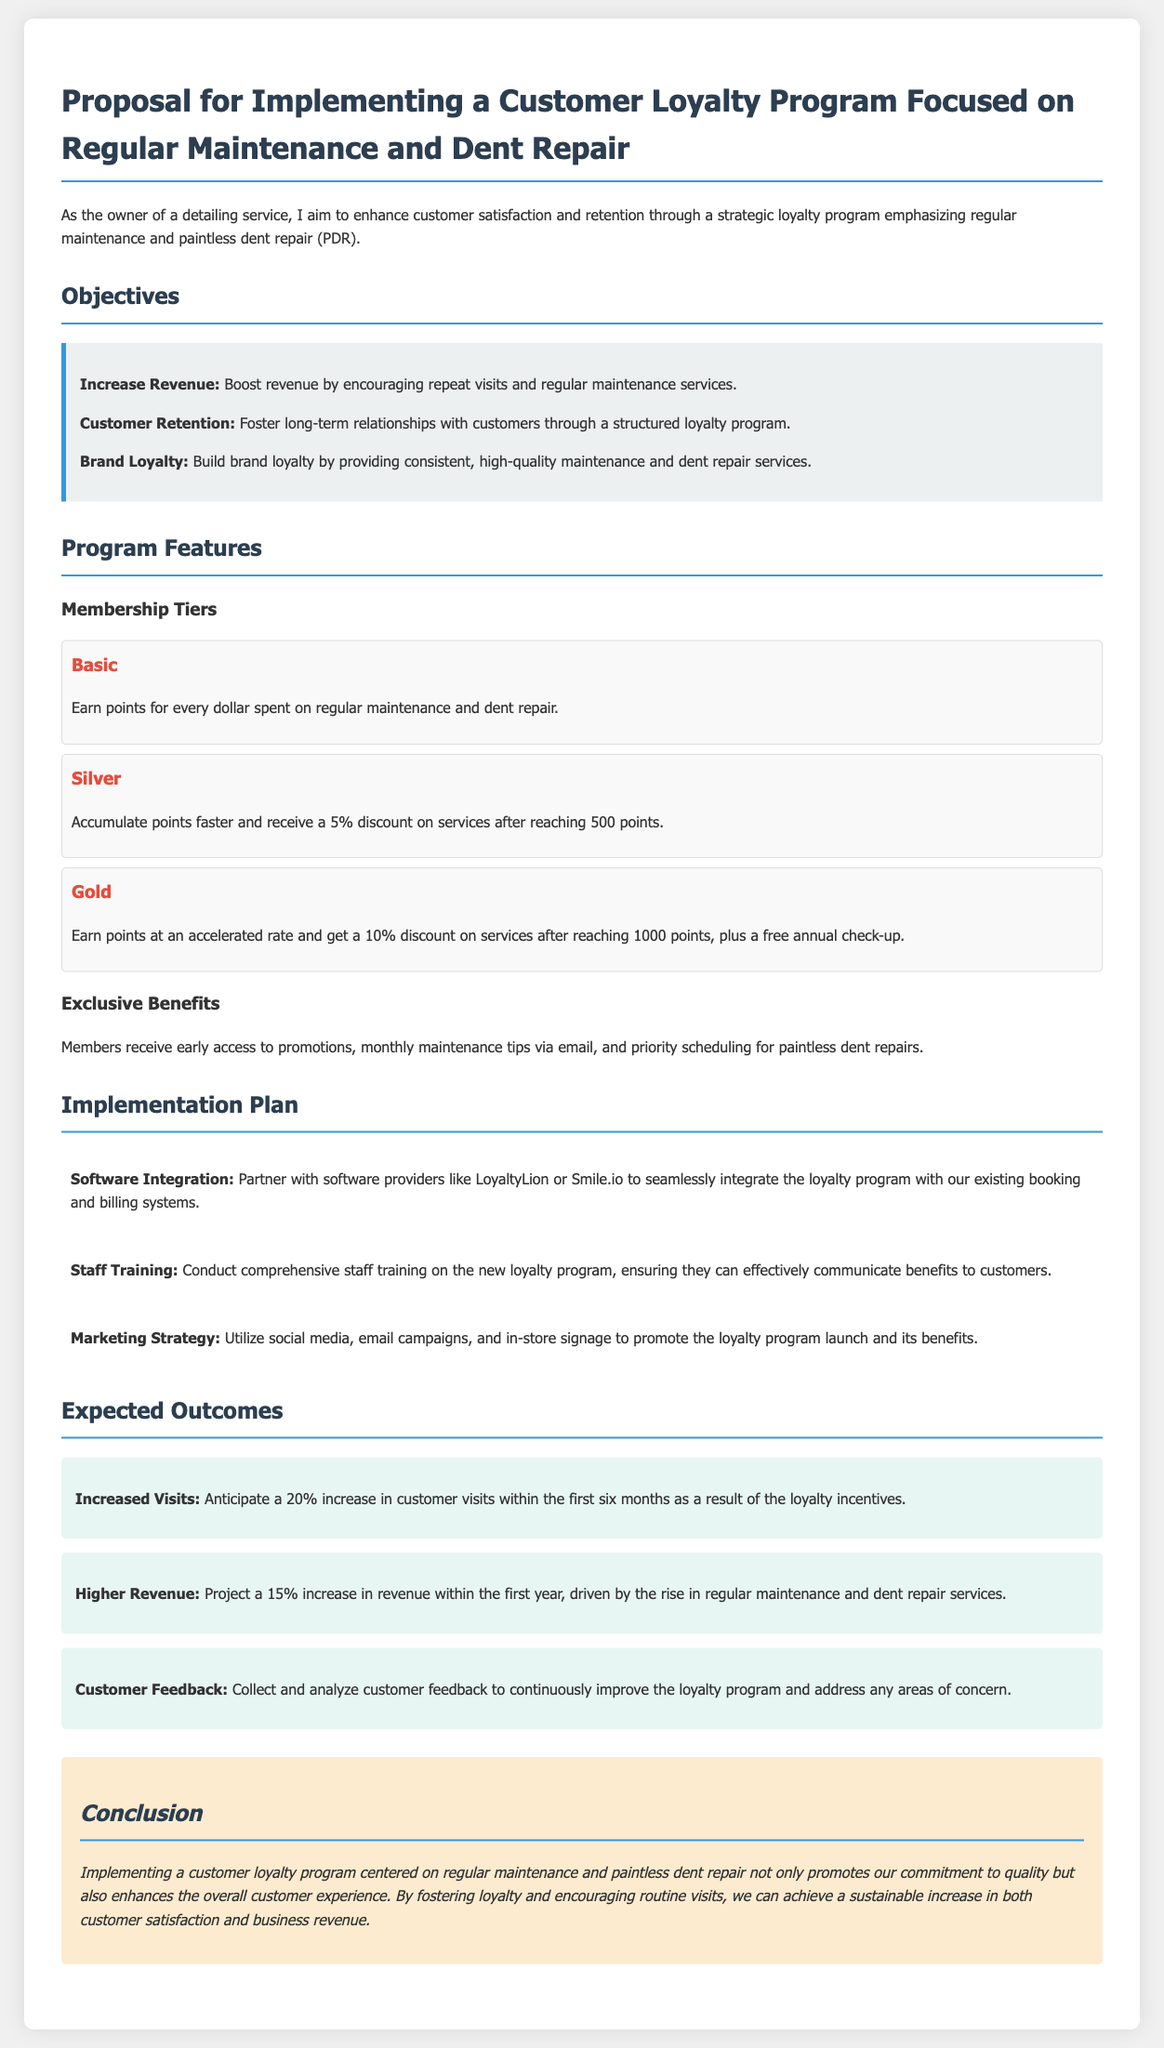what is the title of the proposal? The title of the proposal is stated at the beginning of the document.
Answer: Proposal for Implementing a Customer Loyalty Program Focused on Regular Maintenance and Dent Repair how many membership tiers are there? The proposal lists three membership tiers: Basic, Silver, and Gold.
Answer: Three what discount does the Silver tier provide? The Silver tier offers a discount after reaching a specified points threshold.
Answer: 5% what is the percentage increase in customer visits anticipated within six months? The expected outcome for increased visits is mentioned in the document.
Answer: 20% which software providers are mentioned for integration? The proposal specifies potential partners for software integration.
Answer: LoyaltyLion or Smile.io what is the focus of the loyalty program? The main focus of the loyalty program is to foster ongoing customer engagement.
Answer: Regular maintenance and paintless dent repair what is the expected revenue increase in the first year? The proposal outlines anticipated financial outcomes.
Answer: 15% how will customer feedback be collected according to the proposal? The document indicates a method for gathering and analyzing customer feedback.
Answer: Collect and analyze customer feedback what type of training will staff undergo? The proposal details the nature of training for staff to support the loyalty program.
Answer: Comprehensive staff training 